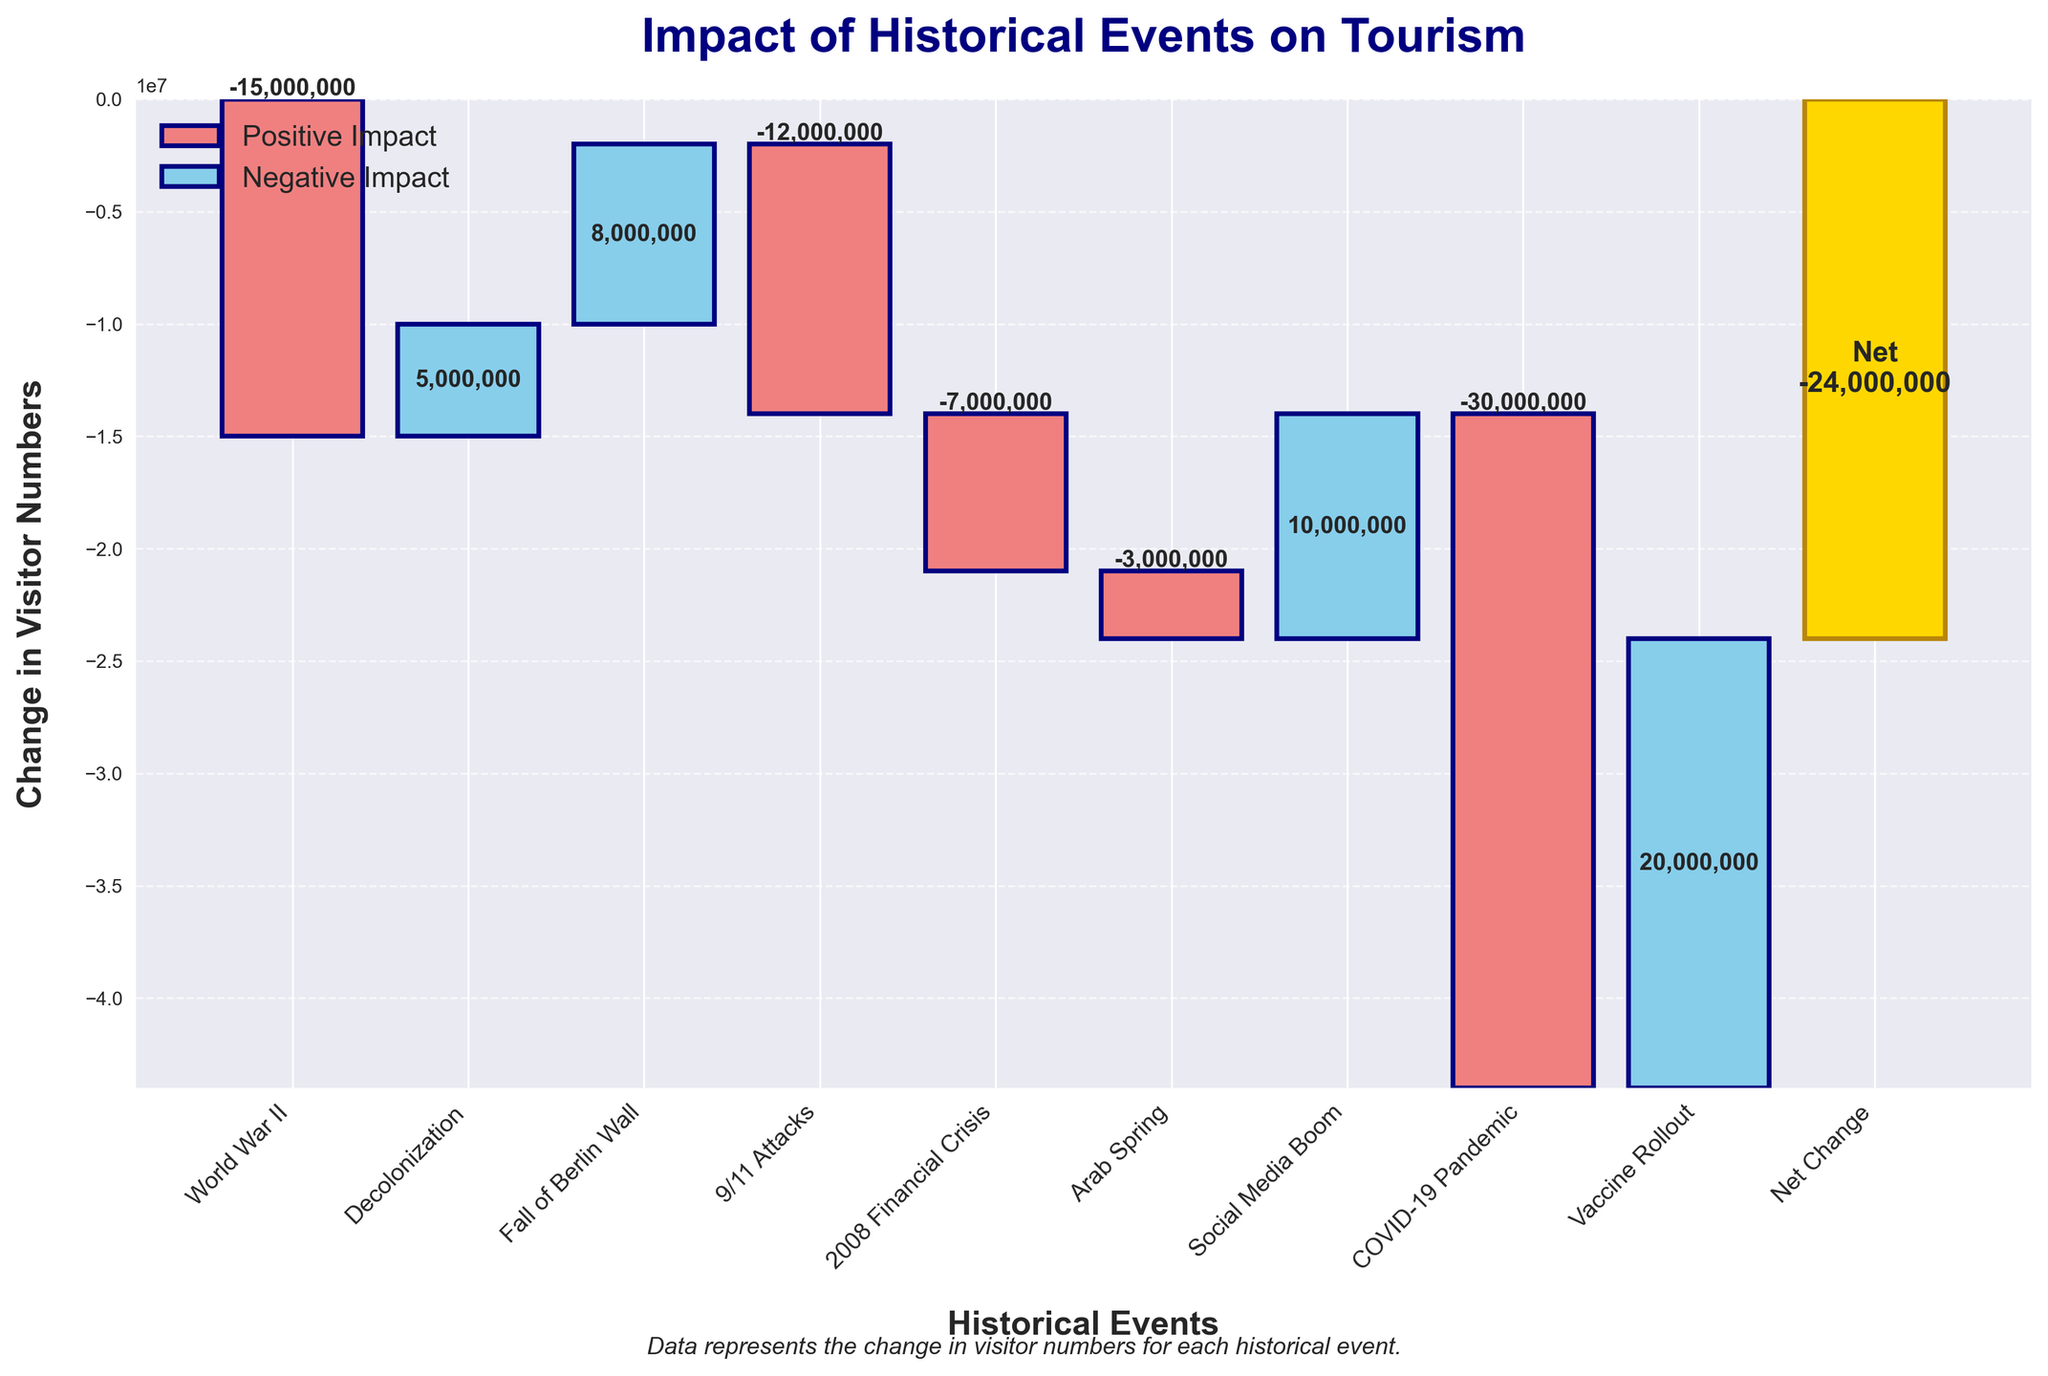Which event caused the largest decrease in visitors? The figure highlights bars in lightcoral for negative impacts, with the biggest such decrease occurring during the COVID-19 Pandemic. This bar reaches -30,000,000 visitors.
Answer: COVID-19 Pandemic How many events had a positive impact on tourism? By looking at the bars colored skyblue, it is evident that there are four events with positive impacts: Decolonization, Fall of Berlin Wall, Social Media Boom, and Vaccine Rollout.
Answer: 4 What is the net change in visitor numbers after all events? The last bar is labeled "Net Change" in gold, and it lists the cumulative change of all events, which is -41,000,000.
Answer: -41,000,000 What was the impact of 9/11 Attacks compared to the 2008 Financial Crisis? The 9/11 Attacks caused a decrease of 12,000,000 visitors, while the 2008 Financial Crisis led to a decrease of 7,000,000 visitors. Comparing these, the 9/11 Attacks had a larger negative impact.
Answer: 9/11 Attacks had a larger negative impact Between which two events was the highest increase in visitor numbers? The two events with the highest bars indicating increases are the Social Media Boom with 10,000,000 and Vaccine Rollout with 20,000,000, with the Vaccine Rollout providing the highest increase.
Answer: Vaccine Rollout What was the combined decrease in visitor numbers due to World War II and the COVID-19 Pandemic? Looking at the figure, World War II caused a decrease of 15,000,000 visitors and the COVID-19 Pandemic caused a decrease of 30,000,000 visitors. Summing these values gives a combined decrease of 45,000,000.
Answer: 45,000,000 Which event had the smallest positive impact on tourism? Among the events with skyblue bars, Decolonization had the smallest positive impact with an increase of 5,000,000 visitors.
Answer: Decolonization How much did tourism decrease during the Arab Spring compared to the Decolonization period? The Arab Spring caused a drop of 3,000,000 visitors, while Decolonization saw an increase of 5,000,000. The net difference is 8,000,000 (5,000,000 increase - 3,000,000 decrease).
Answer: 8,000,000 What’s the combined effect of the Fall of Berlin Wall and the Social Media Boom on tourism numbers? The Fall of the Berlin Wall led to an increase of 8,000,000 visitors and the Social Media Boom added another 10,000,000. The combined effect is 18,000,000 (8,000,000 + 10,000,000).
Answer: 18,000,000 